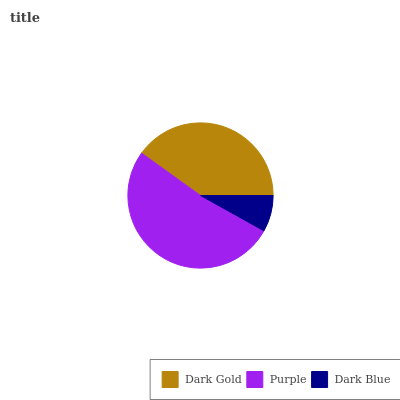Is Dark Blue the minimum?
Answer yes or no. Yes. Is Purple the maximum?
Answer yes or no. Yes. Is Purple the minimum?
Answer yes or no. No. Is Dark Blue the maximum?
Answer yes or no. No. Is Purple greater than Dark Blue?
Answer yes or no. Yes. Is Dark Blue less than Purple?
Answer yes or no. Yes. Is Dark Blue greater than Purple?
Answer yes or no. No. Is Purple less than Dark Blue?
Answer yes or no. No. Is Dark Gold the high median?
Answer yes or no. Yes. Is Dark Gold the low median?
Answer yes or no. Yes. Is Purple the high median?
Answer yes or no. No. Is Dark Blue the low median?
Answer yes or no. No. 